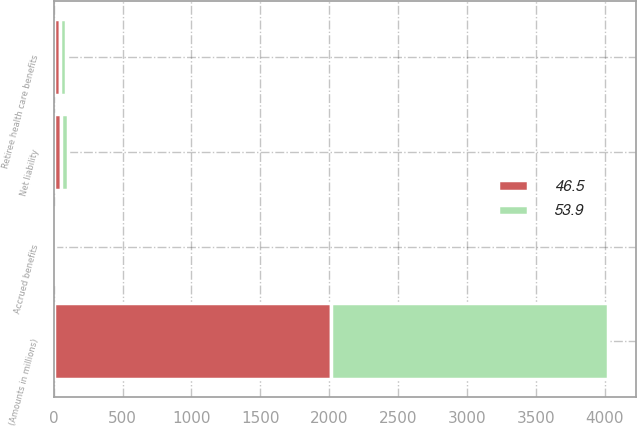<chart> <loc_0><loc_0><loc_500><loc_500><stacked_bar_chart><ecel><fcel>(Amounts in millions)<fcel>Accrued benefits<fcel>Retiree health care benefits<fcel>Net liability<nl><fcel>53.9<fcel>2013<fcel>4.8<fcel>41.7<fcel>46.5<nl><fcel>46.5<fcel>2012<fcel>5.5<fcel>48.4<fcel>53.9<nl></chart> 